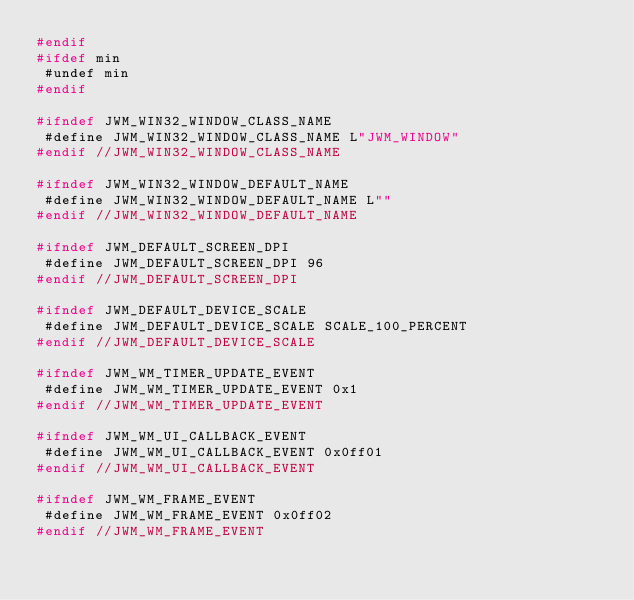Convert code to text. <code><loc_0><loc_0><loc_500><loc_500><_C++_>#endif
#ifdef min
 #undef min
#endif

#ifndef JWM_WIN32_WINDOW_CLASS_NAME
 #define JWM_WIN32_WINDOW_CLASS_NAME L"JWM_WINDOW"
#endif //JWM_WIN32_WINDOW_CLASS_NAME

#ifndef JWM_WIN32_WINDOW_DEFAULT_NAME
 #define JWM_WIN32_WINDOW_DEFAULT_NAME L""
#endif //JWM_WIN32_WINDOW_DEFAULT_NAME

#ifndef JWM_DEFAULT_SCREEN_DPI
 #define JWM_DEFAULT_SCREEN_DPI 96
#endif //JWM_DEFAULT_SCREEN_DPI

#ifndef JWM_DEFAULT_DEVICE_SCALE
 #define JWM_DEFAULT_DEVICE_SCALE SCALE_100_PERCENT
#endif //JWM_DEFAULT_DEVICE_SCALE

#ifndef JWM_WM_TIMER_UPDATE_EVENT
 #define JWM_WM_TIMER_UPDATE_EVENT 0x1
#endif //JWM_WM_TIMER_UPDATE_EVENT

#ifndef JWM_WM_UI_CALLBACK_EVENT
 #define JWM_WM_UI_CALLBACK_EVENT 0x0ff01
#endif //JWM_WM_UI_CALLBACK_EVENT

#ifndef JWM_WM_FRAME_EVENT
 #define JWM_WM_FRAME_EVENT 0x0ff02
#endif //JWM_WM_FRAME_EVENT</code> 